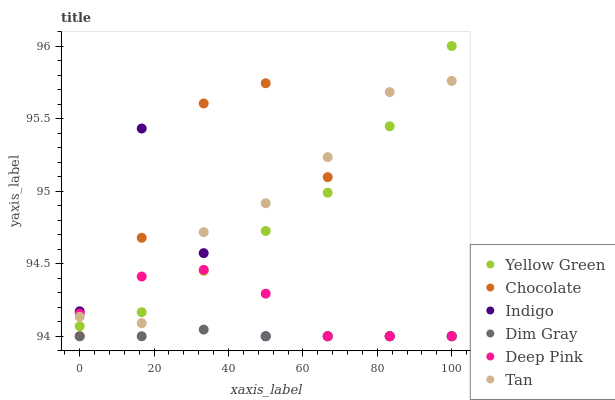Does Dim Gray have the minimum area under the curve?
Answer yes or no. Yes. Does Tan have the maximum area under the curve?
Answer yes or no. Yes. Does Indigo have the minimum area under the curve?
Answer yes or no. No. Does Indigo have the maximum area under the curve?
Answer yes or no. No. Is Dim Gray the smoothest?
Answer yes or no. Yes. Is Chocolate the roughest?
Answer yes or no. Yes. Is Indigo the smoothest?
Answer yes or no. No. Is Indigo the roughest?
Answer yes or no. No. Does Dim Gray have the lowest value?
Answer yes or no. Yes. Does Yellow Green have the lowest value?
Answer yes or no. No. Does Yellow Green have the highest value?
Answer yes or no. Yes. Does Indigo have the highest value?
Answer yes or no. No. Is Dim Gray less than Tan?
Answer yes or no. Yes. Is Yellow Green greater than Dim Gray?
Answer yes or no. Yes. Does Yellow Green intersect Indigo?
Answer yes or no. Yes. Is Yellow Green less than Indigo?
Answer yes or no. No. Is Yellow Green greater than Indigo?
Answer yes or no. No. Does Dim Gray intersect Tan?
Answer yes or no. No. 